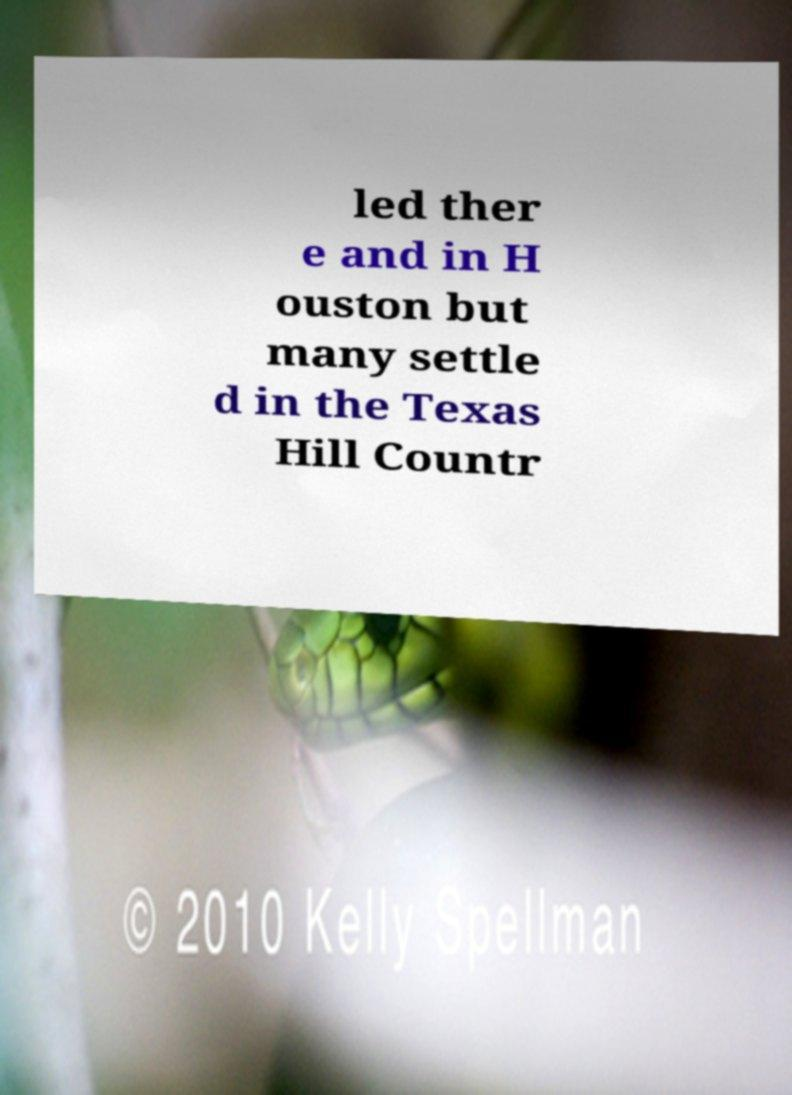I need the written content from this picture converted into text. Can you do that? led ther e and in H ouston but many settle d in the Texas Hill Countr 